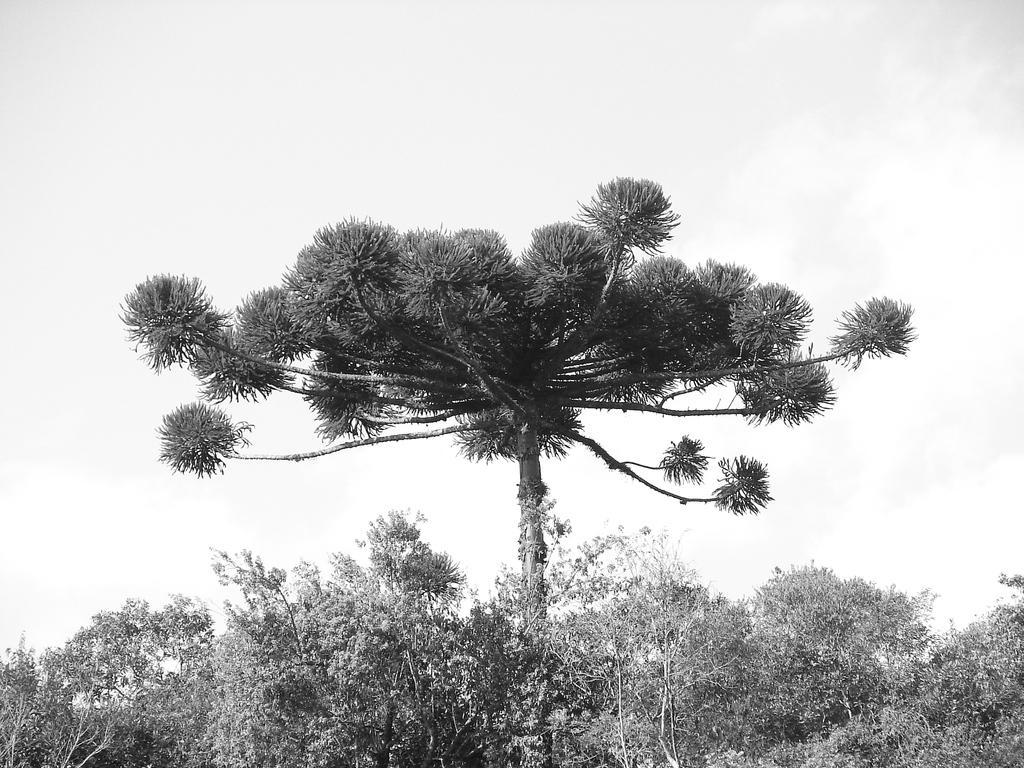Please provide a concise description of this image. In this picture we can see trees. In the background of the image we can see the sky. 